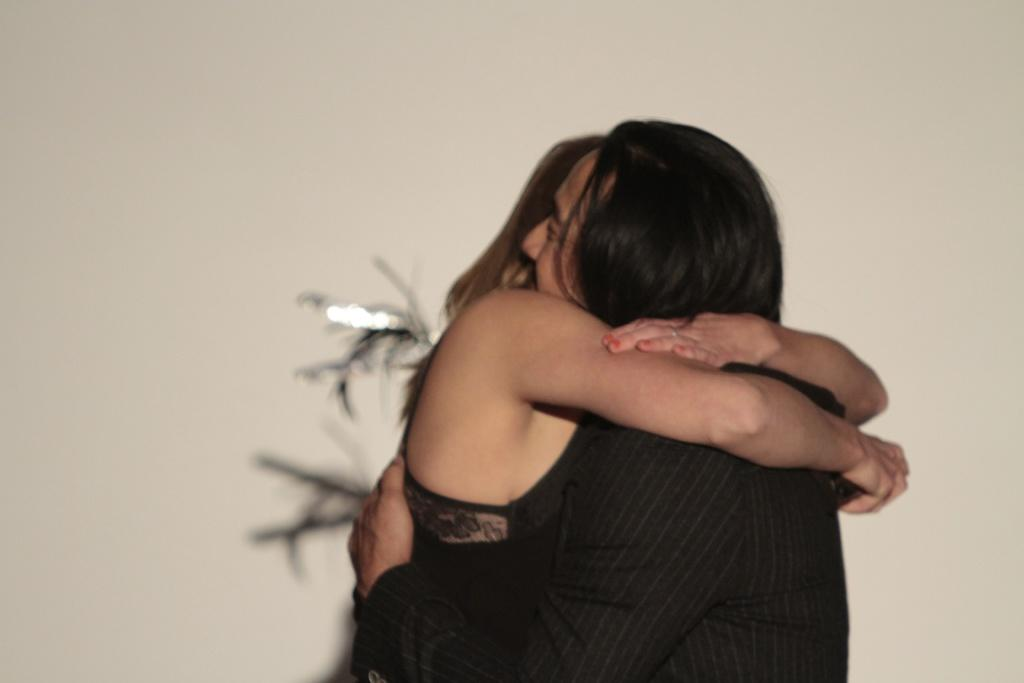How many people are in the image? There are two people in the image, a man and a woman. What are the man and woman doing in the image? The man and woman are standing and hugging. What can be seen in the background of the image? There is a wall in the background of the image. What type of sticks can be seen in the image? There are no sticks present in the image. What type of bushes can be seen growing near the wall in the image? There is no mention of bushes in the image; only a wall is visible in the background. 